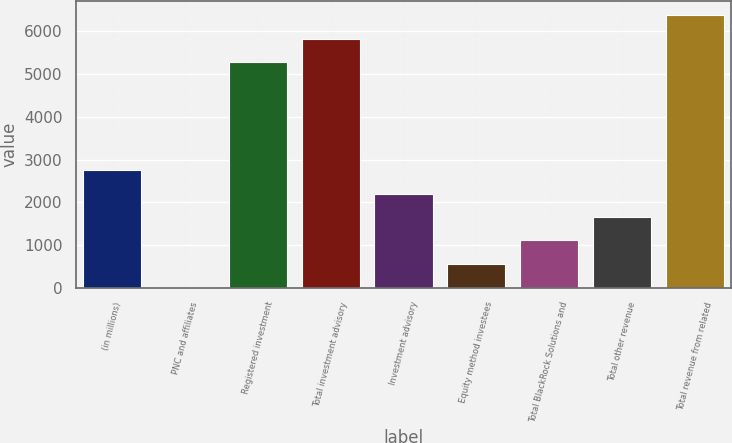Convert chart. <chart><loc_0><loc_0><loc_500><loc_500><bar_chart><fcel>(in millions)<fcel>PNC and affiliates<fcel>Registered investment<fcel>Total investment advisory<fcel>Investment advisory<fcel>Equity method investees<fcel>Total BlackRock Solutions and<fcel>Total other revenue<fcel>Total revenue from related<nl><fcel>2752.5<fcel>4<fcel>5283<fcel>5832.7<fcel>2202.8<fcel>553.7<fcel>1103.4<fcel>1653.1<fcel>6382.4<nl></chart> 